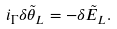<formula> <loc_0><loc_0><loc_500><loc_500>i _ { \Gamma } \delta { \tilde { \theta } } _ { L } = - \delta { \tilde { E } } _ { L } .</formula> 